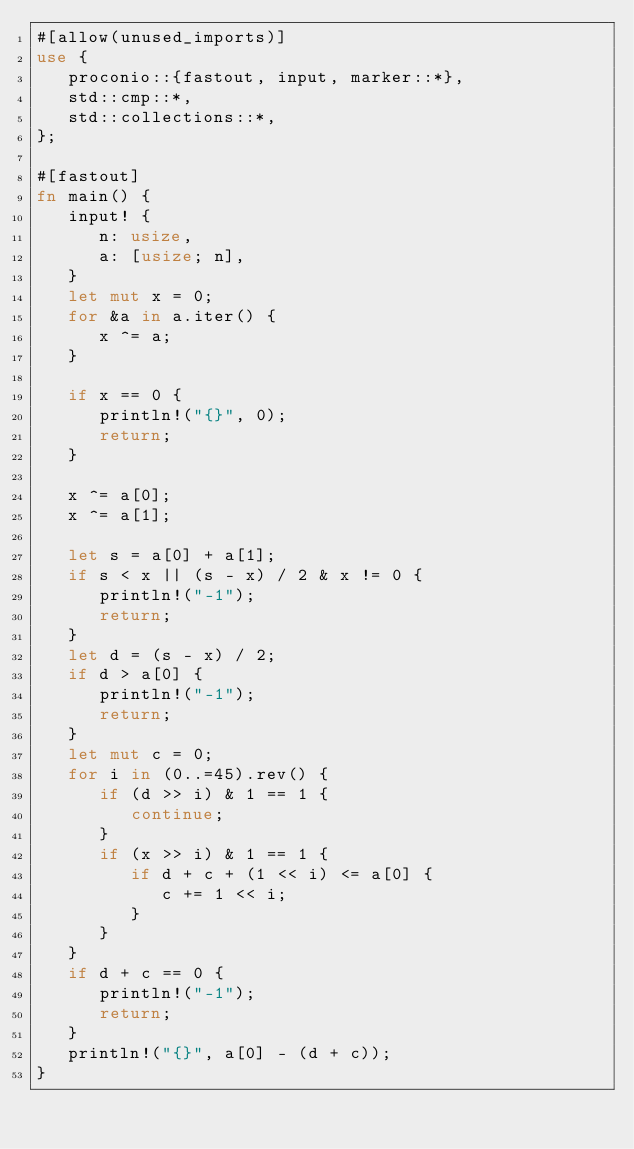<code> <loc_0><loc_0><loc_500><loc_500><_Rust_>#[allow(unused_imports)]
use {
   proconio::{fastout, input, marker::*},
   std::cmp::*,
   std::collections::*,
};

#[fastout]
fn main() {
   input! {
      n: usize,
      a: [usize; n],
   }
   let mut x = 0;
   for &a in a.iter() {
      x ^= a;
   }

   if x == 0 {
      println!("{}", 0);
      return;
   }

   x ^= a[0];
   x ^= a[1];

   let s = a[0] + a[1];
   if s < x || (s - x) / 2 & x != 0 {
      println!("-1");
      return;
   }
   let d = (s - x) / 2;
   if d > a[0] {
      println!("-1");
      return;
   }
   let mut c = 0;
   for i in (0..=45).rev() {
      if (d >> i) & 1 == 1 {
         continue;
      }
      if (x >> i) & 1 == 1 {
         if d + c + (1 << i) <= a[0] {
            c += 1 << i;
         }
      }
   }
   if d + c == 0 {
      println!("-1");
      return;
   }
   println!("{}", a[0] - (d + c));
}
</code> 